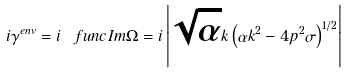Convert formula to latex. <formula><loc_0><loc_0><loc_500><loc_500>i \gamma ^ { e n v } = i \ f u n c { I m } \Omega = i \left | \sqrt { \alpha } k \left ( \alpha k ^ { 2 } - 4 p ^ { 2 } \sigma \right ) ^ { 1 / 2 } \right |</formula> 